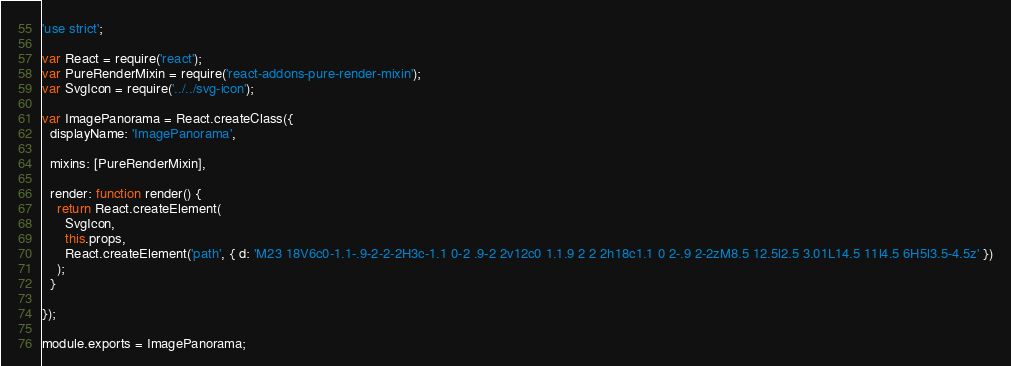<code> <loc_0><loc_0><loc_500><loc_500><_JavaScript_>'use strict';

var React = require('react');
var PureRenderMixin = require('react-addons-pure-render-mixin');
var SvgIcon = require('../../svg-icon');

var ImagePanorama = React.createClass({
  displayName: 'ImagePanorama',

  mixins: [PureRenderMixin],

  render: function render() {
    return React.createElement(
      SvgIcon,
      this.props,
      React.createElement('path', { d: 'M23 18V6c0-1.1-.9-2-2-2H3c-1.1 0-2 .9-2 2v12c0 1.1.9 2 2 2h18c1.1 0 2-.9 2-2zM8.5 12.5l2.5 3.01L14.5 11l4.5 6H5l3.5-4.5z' })
    );
  }

});

module.exports = ImagePanorama;</code> 